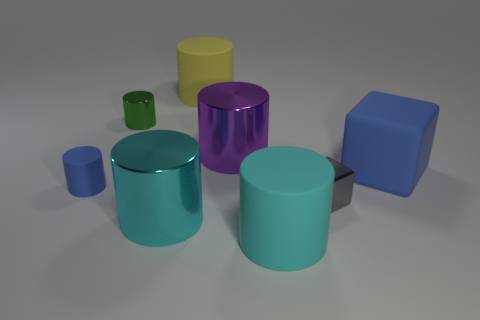Subtract all green cylinders. How many cylinders are left? 5 Subtract all yellow rubber cylinders. How many cylinders are left? 5 Subtract all purple cylinders. Subtract all purple cubes. How many cylinders are left? 5 Add 1 tiny green metal objects. How many objects exist? 9 Subtract all blocks. How many objects are left? 6 Subtract 1 yellow cylinders. How many objects are left? 7 Subtract all large green metallic balls. Subtract all gray cubes. How many objects are left? 7 Add 7 small blocks. How many small blocks are left? 8 Add 3 big matte cylinders. How many big matte cylinders exist? 5 